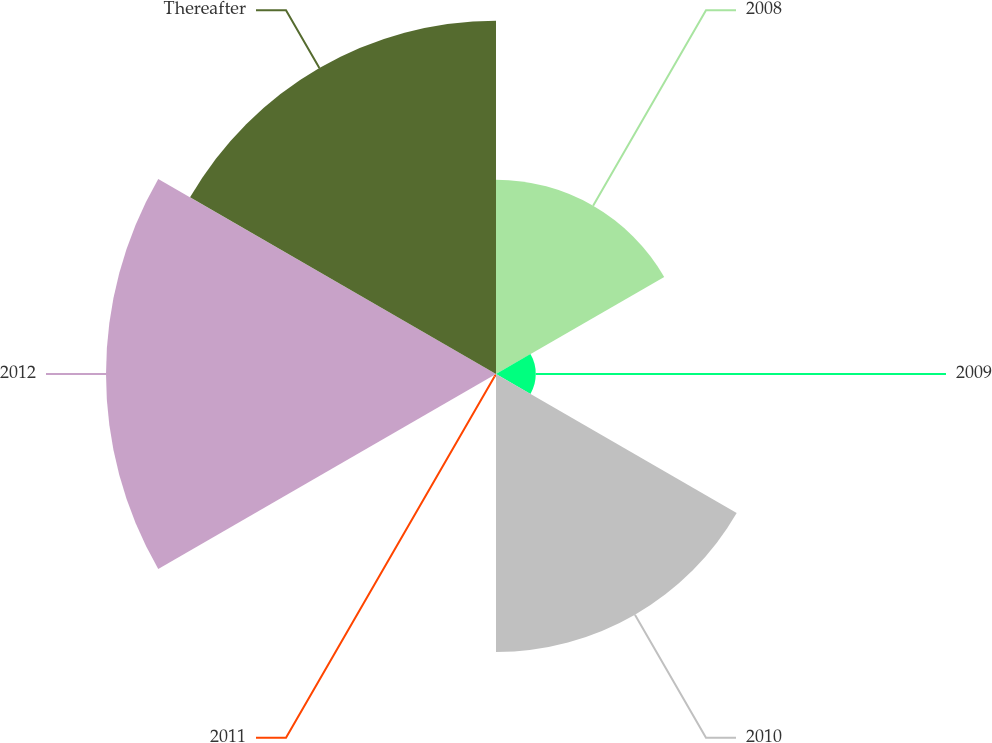Convert chart to OTSL. <chart><loc_0><loc_0><loc_500><loc_500><pie_chart><fcel>2008<fcel>2009<fcel>2010<fcel>2011<fcel>2012<fcel>Thereafter<nl><fcel>15.44%<fcel>3.16%<fcel>22.09%<fcel>0.23%<fcel>31.0%<fcel>28.08%<nl></chart> 